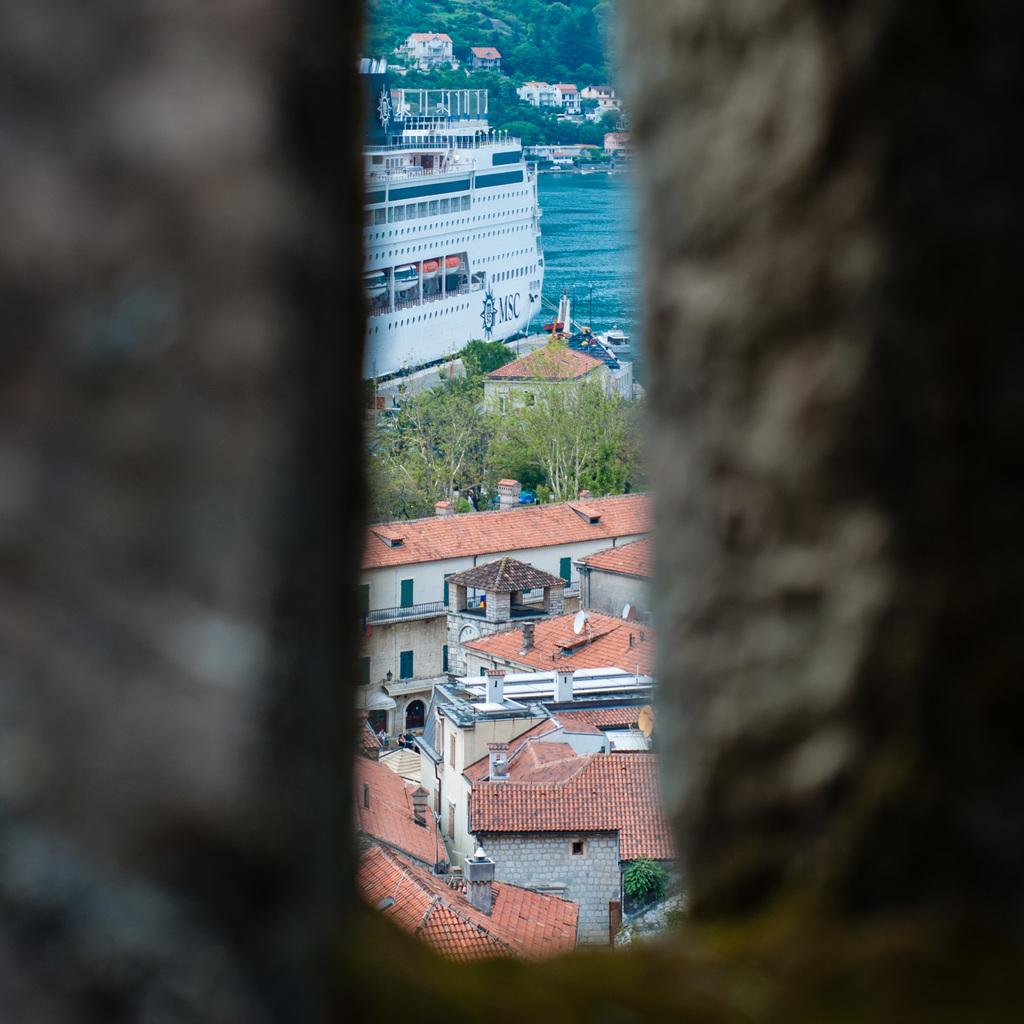What colors are used for the buildings in the image? The buildings in the image are in brown and cream color. What type of vehicle can be seen in the image? There is a ship in white color in the image. Where is the ship located in the image? The ship is in water in the image. What type of vegetation is present in the image? There are trees in green color in the image. How many pairs of shoes can be seen hanging from the trees in the image? There are no shoes hanging from the trees in the image; only trees and buildings are present. Is there a fireman present in the image? There is no fireman present in the image; it features a ship, buildings, and trees. 